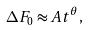Convert formula to latex. <formula><loc_0><loc_0><loc_500><loc_500>\Delta F _ { 0 } \approx A t ^ { \theta } ,</formula> 